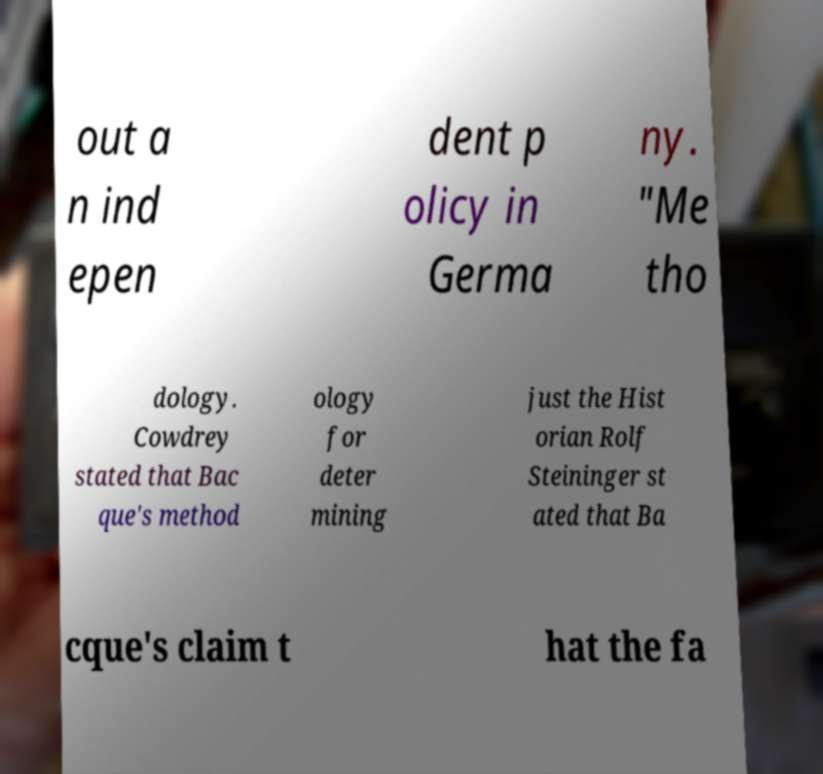Can you read and provide the text displayed in the image?This photo seems to have some interesting text. Can you extract and type it out for me? out a n ind epen dent p olicy in Germa ny. "Me tho dology. Cowdrey stated that Bac que's method ology for deter mining just the Hist orian Rolf Steininger st ated that Ba cque's claim t hat the fa 